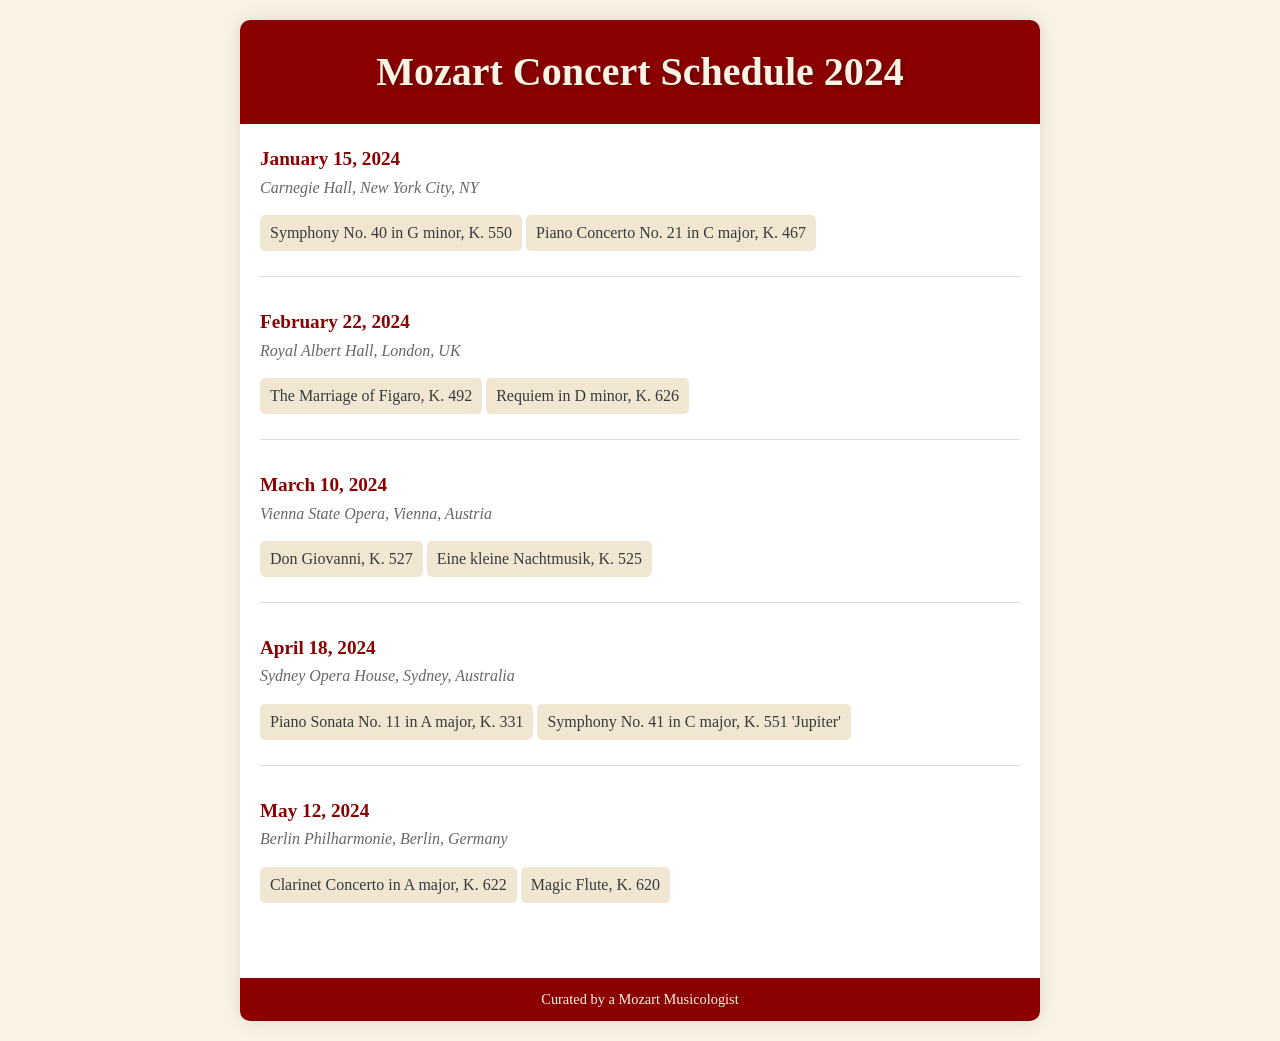What is the date of the concert at Carnegie Hall? The concert at Carnegie Hall is scheduled for January 15, 2024.
Answer: January 15, 2024 Which work is featured at the Vienna State Opera? One of the works featured at the Vienna State Opera is Don Giovanni, K. 527.
Answer: Don Giovanni, K. 527 What is the venue for the concert on February 22, 2024? The venue for the concert on February 22, 2024, is Royal Albert Hall, London, UK.
Answer: Royal Albert Hall, London, UK How many works are performed at the Sydney Opera House concert? The concert at Sydney Opera House features two works: Piano Sonata No. 11 in A major, K. 331 and Symphony No. 41 in C major, K. 551.
Answer: Two works What is the last concert date mentioned in the schedule? The last concert date mentioned in the schedule is May 12, 2024.
Answer: May 12, 2024 Which piece is performed on April 18, 2024? One of the pieces performed on April 18, 2024, is Symphony No. 41 in C major, K. 551 'Jupiter'.
Answer: Symphony No. 41 in C major, K. 551 'Jupiter' How many concerts feature a piano concerto? Two concerts feature a piano concerto: January 15 and May 12.
Answer: Two concerts What is the name of the orchestra at the Berlin Philharmonie concert? The document does not specify the name of the orchestra at the Berlin Philharmonie concert.
Answer: Not specified 